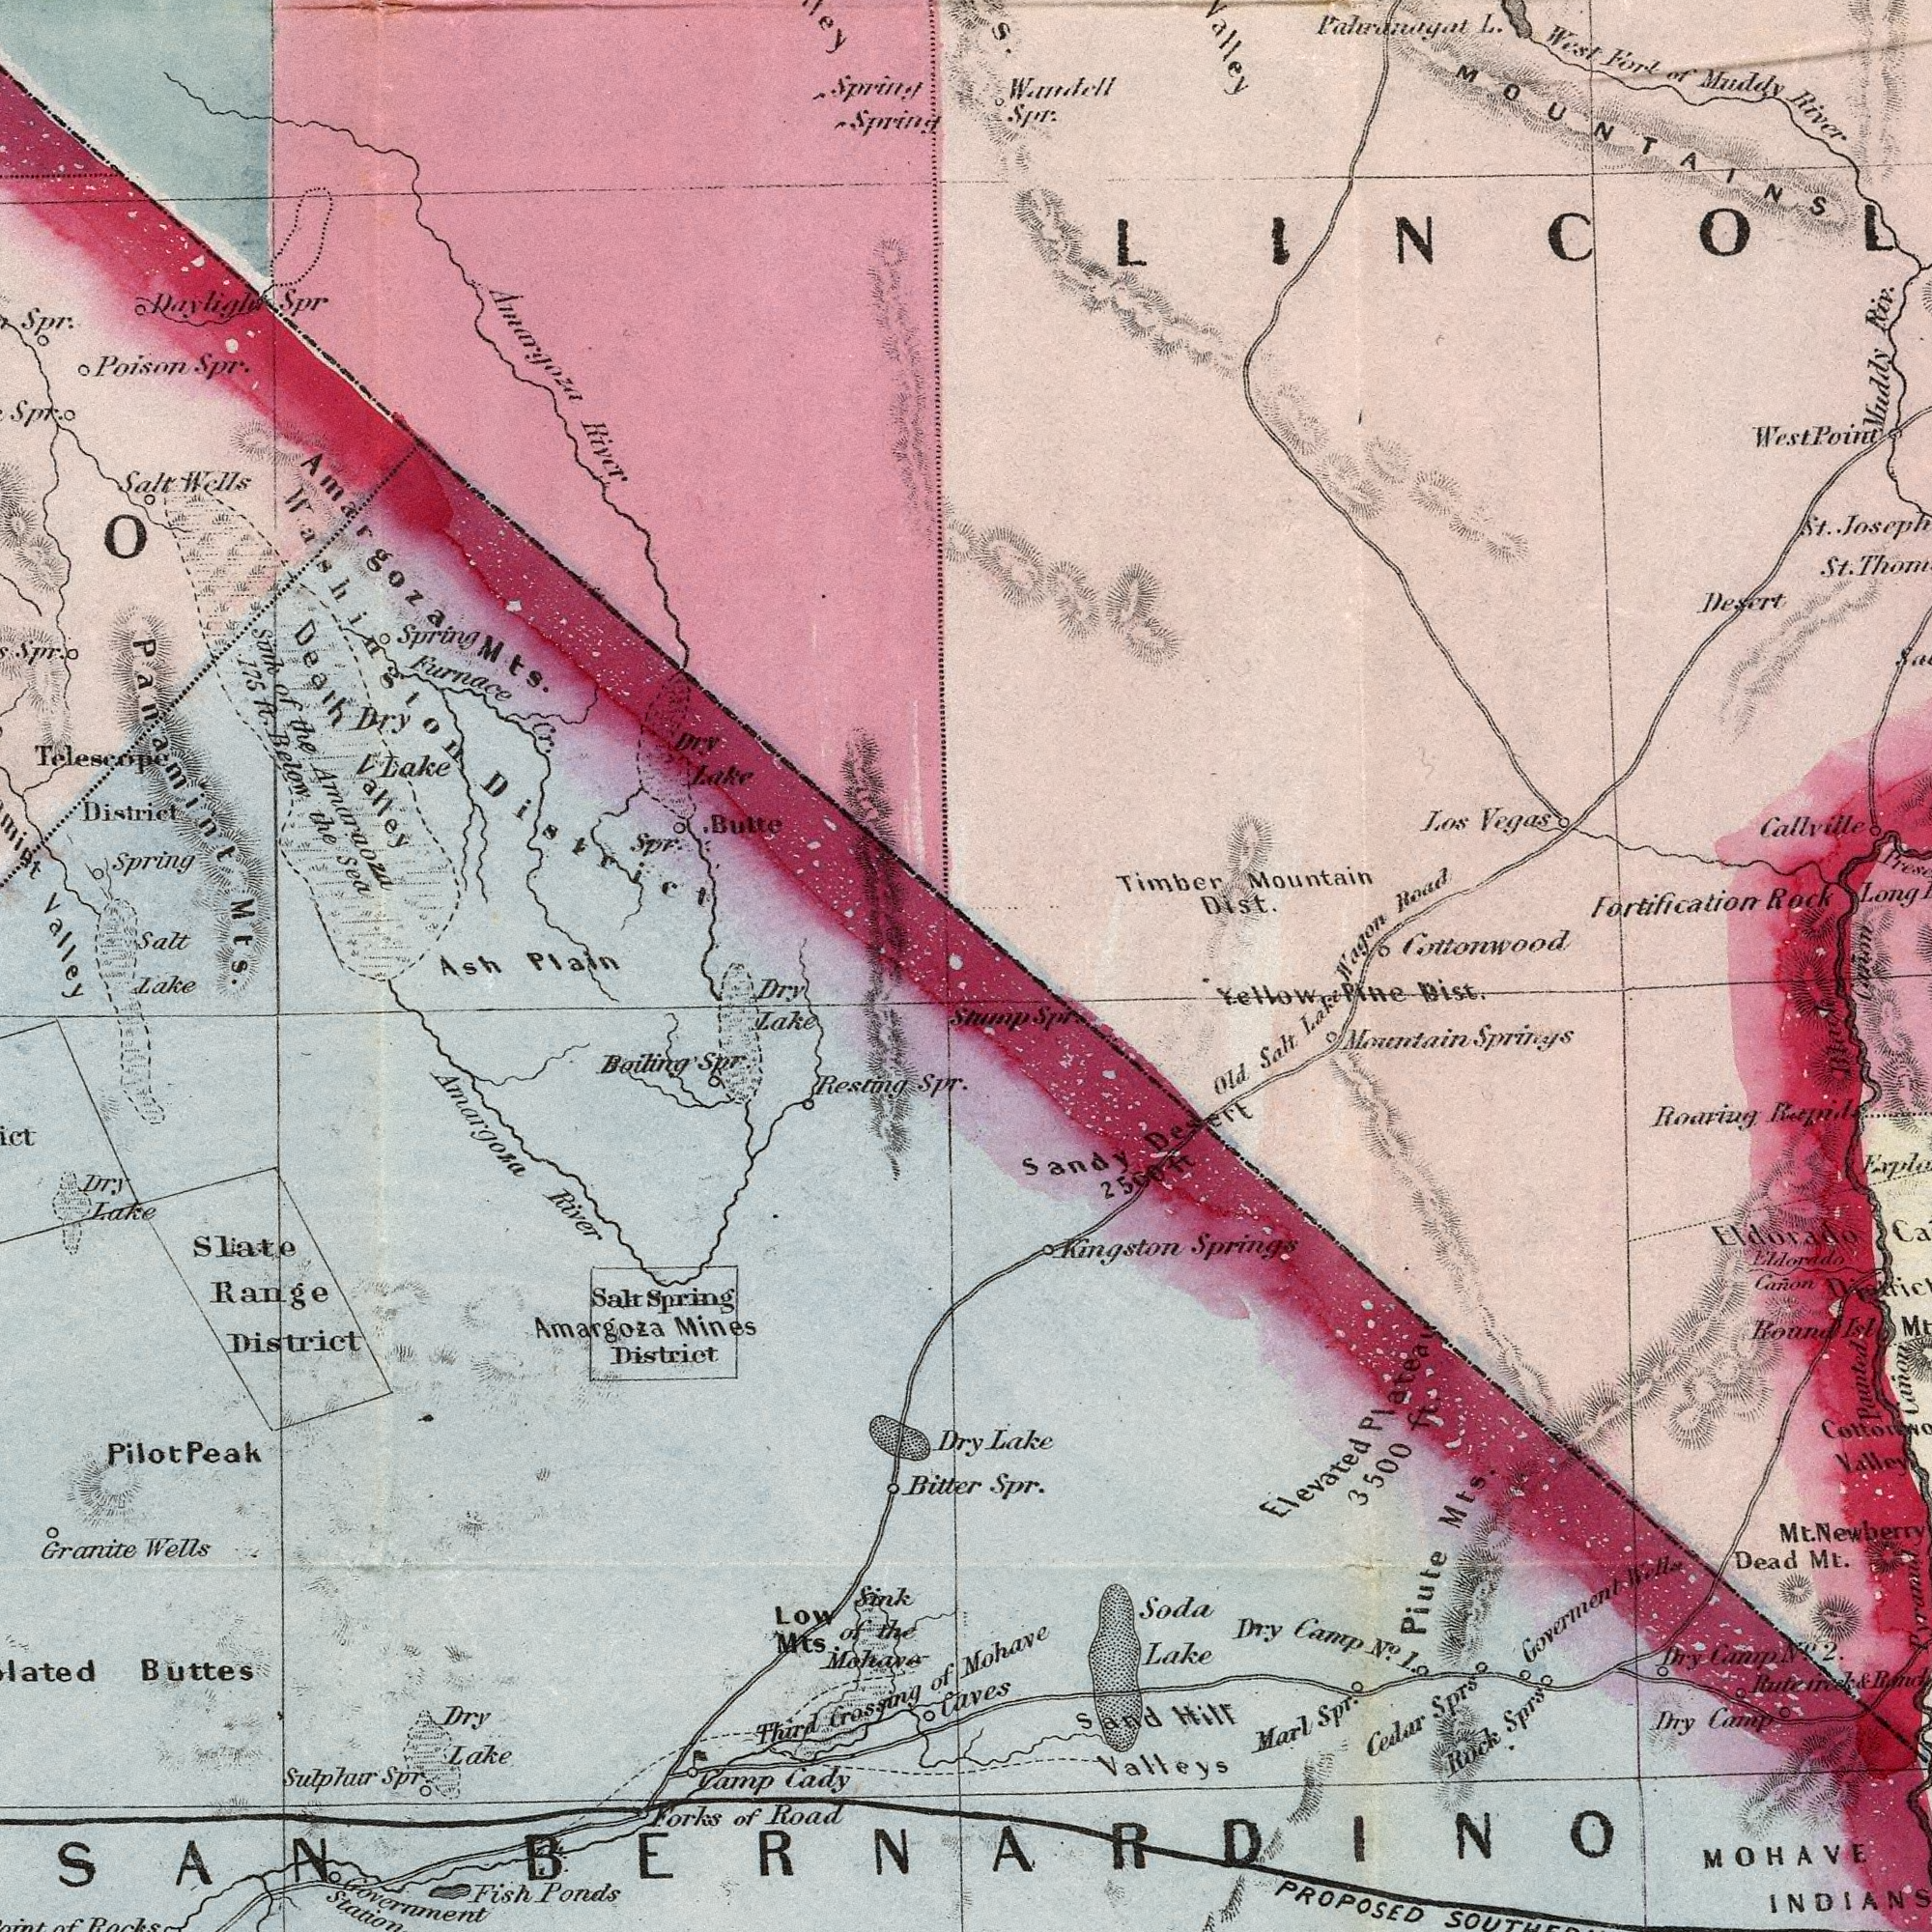What text is shown in the top-left quadrant? Sine of the Amaraoza 175 ft. Below the Sed Death Valley Furnace Cr. Amargoza River Salt Wells Daylight Spr Spring Spring Panamint Mts. Poison Spr. Spring Salt O Dry Lake Butte Spr. Spr. Dry Lake Telescope District Valley Spr. Spring Washington District Spr. Amargoza Mts. Ash Plain What text appears in the bottom-left area of the image? Lake Fish Ponds Resting Spr. Granite Wells Sliate Range District Forks of Road SAN Buttes Govermment Station Salt Spring District Dry Lake Amargoza Mines Dry Lake Sink of the Mahave Low Mts Boiling Spr. Amargoza River Dry Lake Vamp Cady Sulphur Spr. Bitte Third Crossing of Dry Rocks Pilot Peak What text is visible in the upper-right corner? L. Timber Mountain Dist. Los Vegas Fortification Rock Long West Fort of Muddy River Callville St. Muddy Riv. Valley St. Wagon Road Spr. West Point Desert Cottonwood S. MOUNTAINS What text is shown in the bottom-right quadrant? Old Salt Lake BERNARDINO Spr. Mohave Caves Lake PROPOSED MOHAVE Kingston Springs Dry Camp NO. 1. Eldorado Roaring and Hill Valleys Eldorado Canon Elevated Plateal 3500 ft. Mountain Springs Parned Canon Round Isl Marl Spr. Yellow Pine Dist. Rock Sprs Dry Camp NO. 2 Dead Mt. Soda Lake Dry Camp Sandy Desert 2500 ft Piute Mts. Cedar Sprs Valley Gowerment W. H. Ruteined & Stump Spr Mt. Newberry 